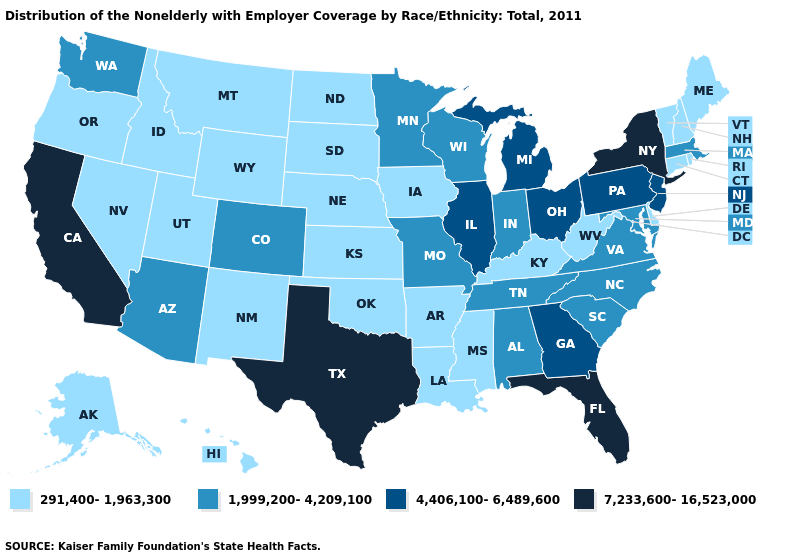Does Mississippi have a higher value than North Dakota?
Answer briefly. No. Name the states that have a value in the range 291,400-1,963,300?
Be succinct. Alaska, Arkansas, Connecticut, Delaware, Hawaii, Idaho, Iowa, Kansas, Kentucky, Louisiana, Maine, Mississippi, Montana, Nebraska, Nevada, New Hampshire, New Mexico, North Dakota, Oklahoma, Oregon, Rhode Island, South Dakota, Utah, Vermont, West Virginia, Wyoming. What is the highest value in states that border Vermont?
Answer briefly. 7,233,600-16,523,000. Does Rhode Island have the highest value in the USA?
Short answer required. No. What is the value of Rhode Island?
Give a very brief answer. 291,400-1,963,300. Does Alabama have the lowest value in the USA?
Quick response, please. No. What is the highest value in the MidWest ?
Answer briefly. 4,406,100-6,489,600. What is the highest value in the South ?
Concise answer only. 7,233,600-16,523,000. Name the states that have a value in the range 7,233,600-16,523,000?
Keep it brief. California, Florida, New York, Texas. Does Virginia have the highest value in the South?
Write a very short answer. No. Which states hav the highest value in the Northeast?
Quick response, please. New York. What is the lowest value in the Northeast?
Write a very short answer. 291,400-1,963,300. Name the states that have a value in the range 1,999,200-4,209,100?
Write a very short answer. Alabama, Arizona, Colorado, Indiana, Maryland, Massachusetts, Minnesota, Missouri, North Carolina, South Carolina, Tennessee, Virginia, Washington, Wisconsin. What is the value of South Dakota?
Keep it brief. 291,400-1,963,300. 